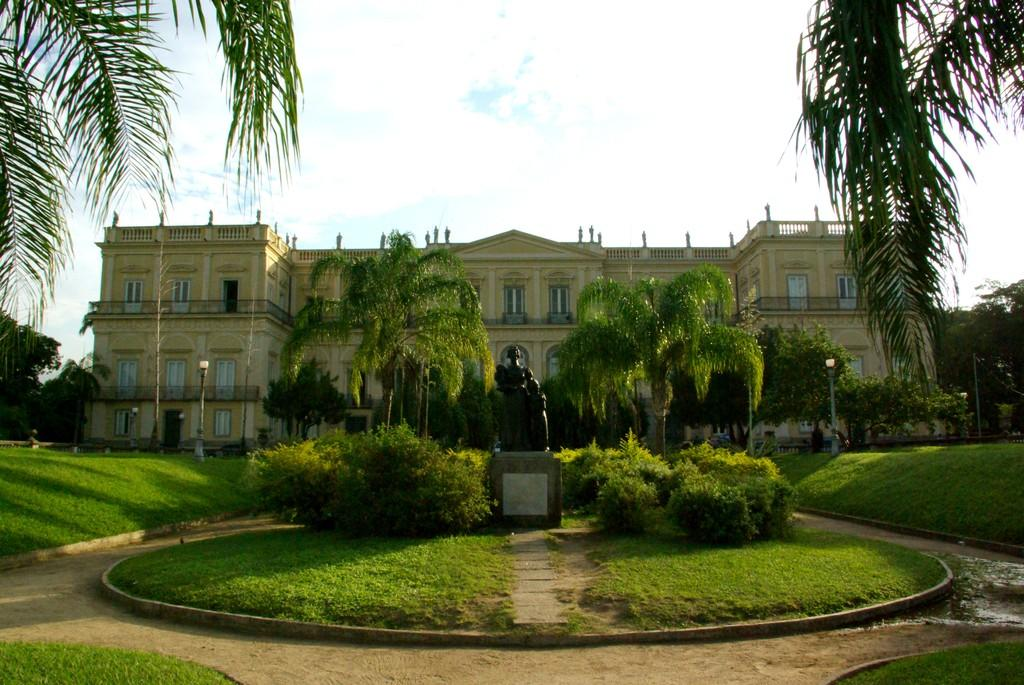What type of structure is present in the image? There is a building in the image. What type of vegetation can be seen in the image? There are plants, grass, and trees visible in the image. What is the statue in the image depicting? The specific details of the statue are not mentioned, but it is present in the image. What type of lighting is present in the background of the image? There are pole lights in the background of the image. What is visible in the background of the image? The sky and other objects on the ground are visible in the background of the image. Can you tell me how many people are smiling in the image? There is no information about people smiling in the image, as the facts provided do not mention any people. Is there a baseball game happening in the image? There is no mention of a baseball game or any sports-related activity in the image. 